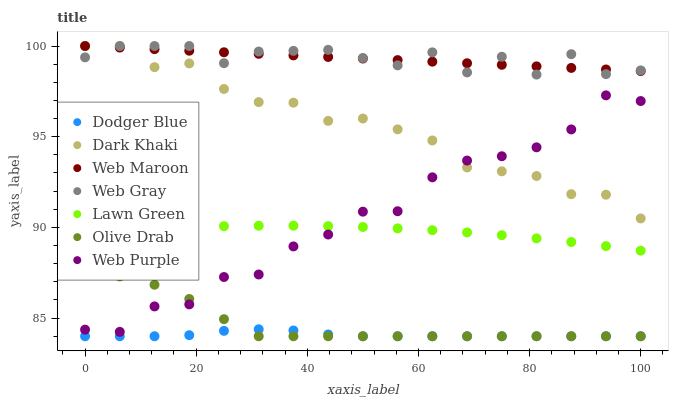Does Dodger Blue have the minimum area under the curve?
Answer yes or no. Yes. Does Web Gray have the maximum area under the curve?
Answer yes or no. Yes. Does Web Maroon have the minimum area under the curve?
Answer yes or no. No. Does Web Maroon have the maximum area under the curve?
Answer yes or no. No. Is Web Maroon the smoothest?
Answer yes or no. Yes. Is Web Purple the roughest?
Answer yes or no. Yes. Is Web Gray the smoothest?
Answer yes or no. No. Is Web Gray the roughest?
Answer yes or no. No. Does Dodger Blue have the lowest value?
Answer yes or no. Yes. Does Web Gray have the lowest value?
Answer yes or no. No. Does Dark Khaki have the highest value?
Answer yes or no. Yes. Does Web Purple have the highest value?
Answer yes or no. No. Is Dodger Blue less than Lawn Green?
Answer yes or no. Yes. Is Dark Khaki greater than Lawn Green?
Answer yes or no. Yes. Does Web Gray intersect Dark Khaki?
Answer yes or no. Yes. Is Web Gray less than Dark Khaki?
Answer yes or no. No. Is Web Gray greater than Dark Khaki?
Answer yes or no. No. Does Dodger Blue intersect Lawn Green?
Answer yes or no. No. 